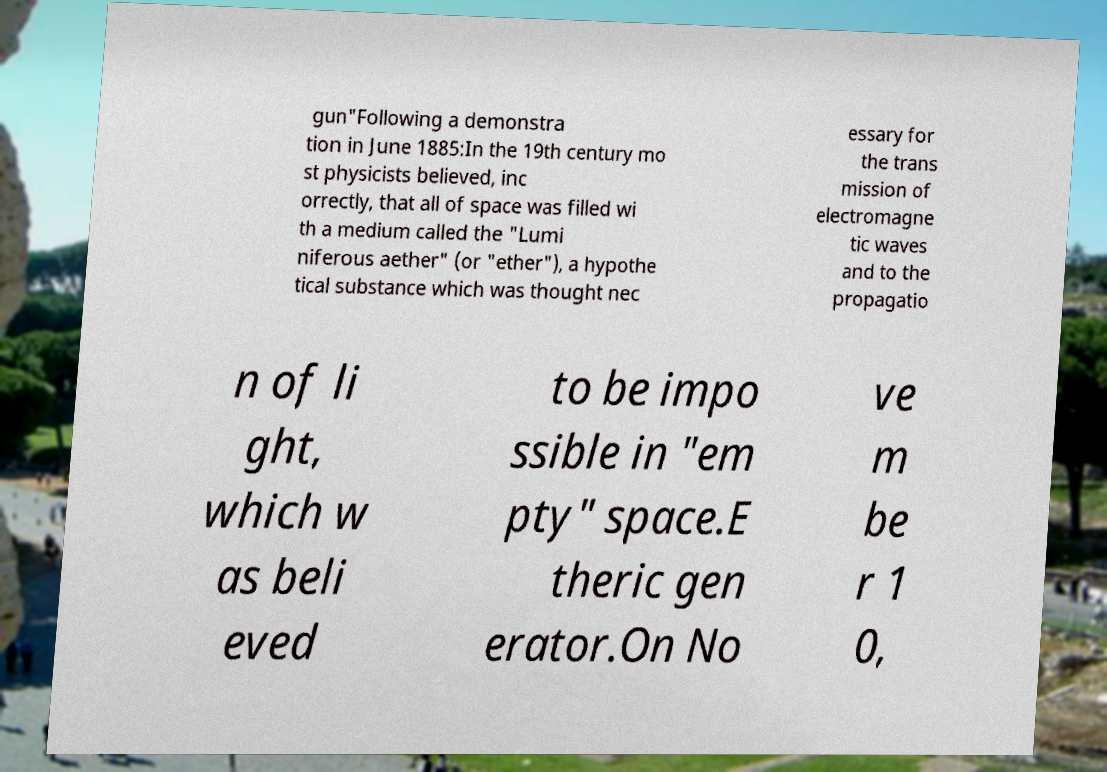Can you accurately transcribe the text from the provided image for me? gun"Following a demonstra tion in June 1885:In the 19th century mo st physicists believed, inc orrectly, that all of space was filled wi th a medium called the "Lumi niferous aether" (or "ether"), a hypothe tical substance which was thought nec essary for the trans mission of electromagne tic waves and to the propagatio n of li ght, which w as beli eved to be impo ssible in "em pty" space.E theric gen erator.On No ve m be r 1 0, 